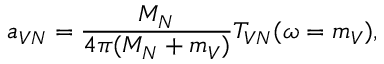<formula> <loc_0><loc_0><loc_500><loc_500>a _ { V N } = \frac { M _ { N } } { 4 \pi ( M _ { N } + m _ { V } ) } T _ { V N } ( \omega = m _ { V } ) ,</formula> 